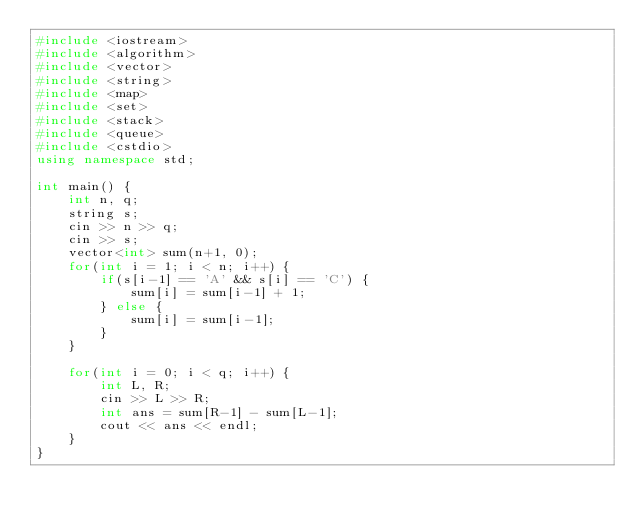<code> <loc_0><loc_0><loc_500><loc_500><_C++_>#include <iostream>
#include <algorithm>
#include <vector>
#include <string>
#include <map>
#include <set>
#include <stack>
#include <queue>
#include <cstdio>
using namespace std;

int main() {
    int n, q;
    string s;
    cin >> n >> q;
    cin >> s;
    vector<int> sum(n+1, 0);
    for(int i = 1; i < n; i++) {
        if(s[i-1] == 'A' && s[i] == 'C') {
            sum[i] = sum[i-1] + 1;
        } else {
            sum[i] = sum[i-1];
        }
    }

    for(int i = 0; i < q; i++) {
        int L, R;
        cin >> L >> R;
        int ans = sum[R-1] - sum[L-1];
        cout << ans << endl;
    }
}

</code> 